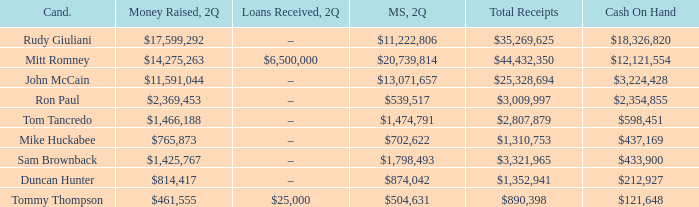Name the money spent for 2Q having candidate of john mccain $13,071,657. 